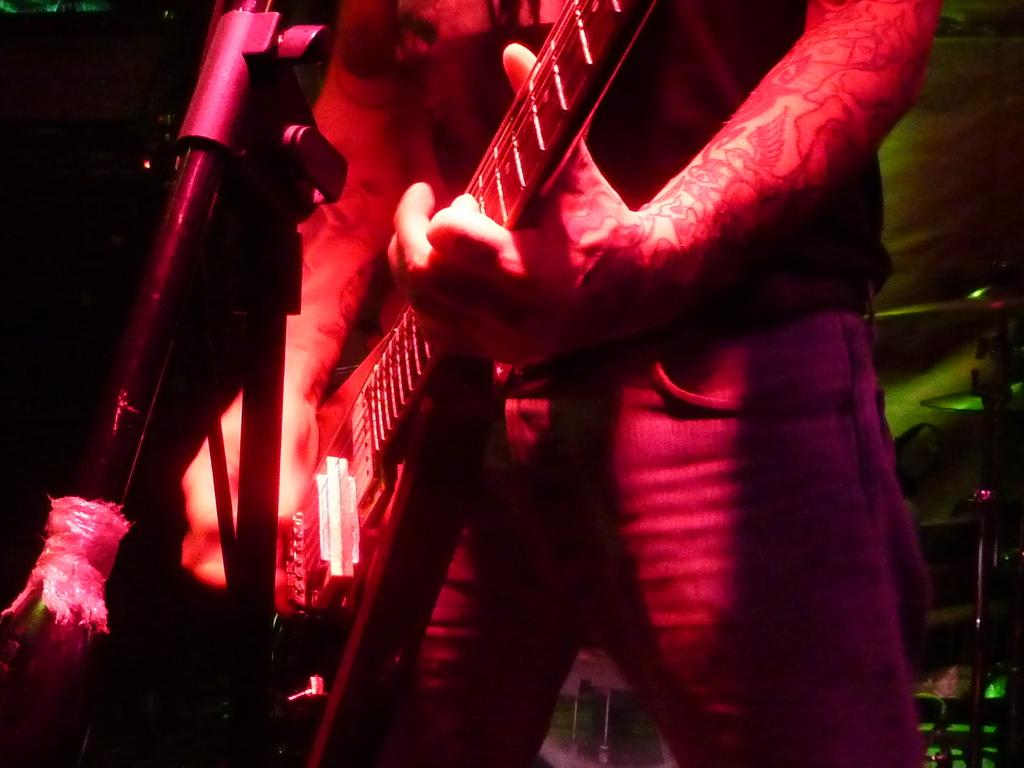What body parts are visible in the image? There are human hands in the image. What are the hands doing in the image? The hands are holding a musical instrument. What type of doll is sitting on the pot in the image? There is no doll or pot present in the image; it only features human hands holding a musical instrument. 